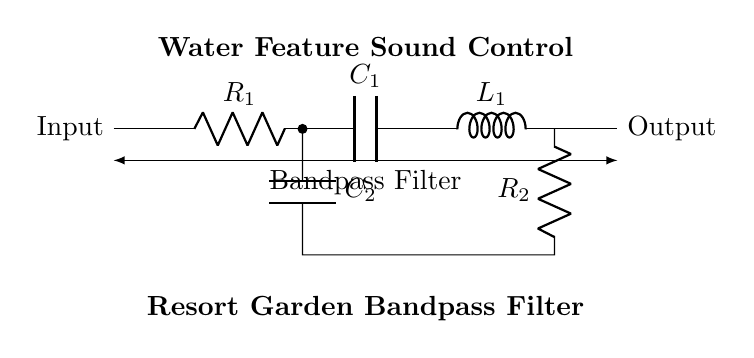What components are present in the bandpass filter? The components in the bandpass filter include two resistors, two capacitors, and one inductor. These components are visually identifiable in the circuit diagram with the labels R, C, and L.
Answer: Resistors, capacitors, and inductor What is the role of the inductor in this circuit? The inductor's role in the bandpass filter is to store energy in a magnetic field, which allows it to selectively pass certain frequency signals while rejecting others. This is key in filtering out unwanted noise from the water feature sounds.
Answer: Energy storage and frequency filtering How many capacitors are used in the bandpass filter? There are two capacitors shown in the circuit diagram. The labels indicate that one capacitor is at the input section and the second capacitor is connected in parallel with one of the resistors.
Answer: Two What is the configuration of resistors in the circuit? The resistors in the circuit are configured in series and parallel arrangements, which influence the cutoff frequencies of the bandpass filter. This configuration allows the filter to define the frequency range that is allowed to pass through while attenuating frequencies outside this range.
Answer: Series and parallel What is the purpose of this bandpass filter in resort gardens? The purpose of this bandpass filter in resort gardens is to control the sound of water features, allowing specific sound frequencies to pass through while eliminating distracting noise, enhancing the overall atmosphere for guests.
Answer: Sound control for water features What is the input and output of the circuit? The input of the circuit is where the sound signal is introduced, typically representing unwanted noise, while the output is where the filtered sound signal is delivered, allowing only the desired frequencies related to water features.
Answer: Input and output 